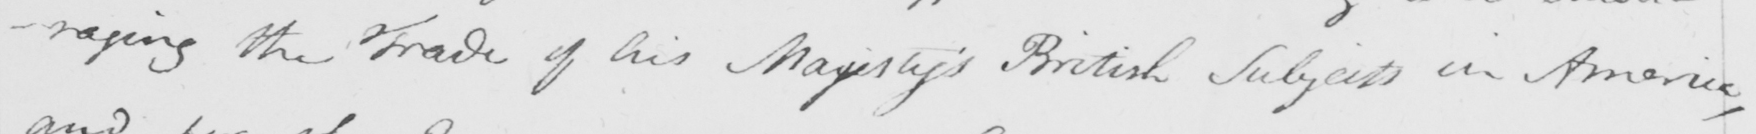What does this handwritten line say? -raging the Trade of his Majesty ' s British Subjects in America , 